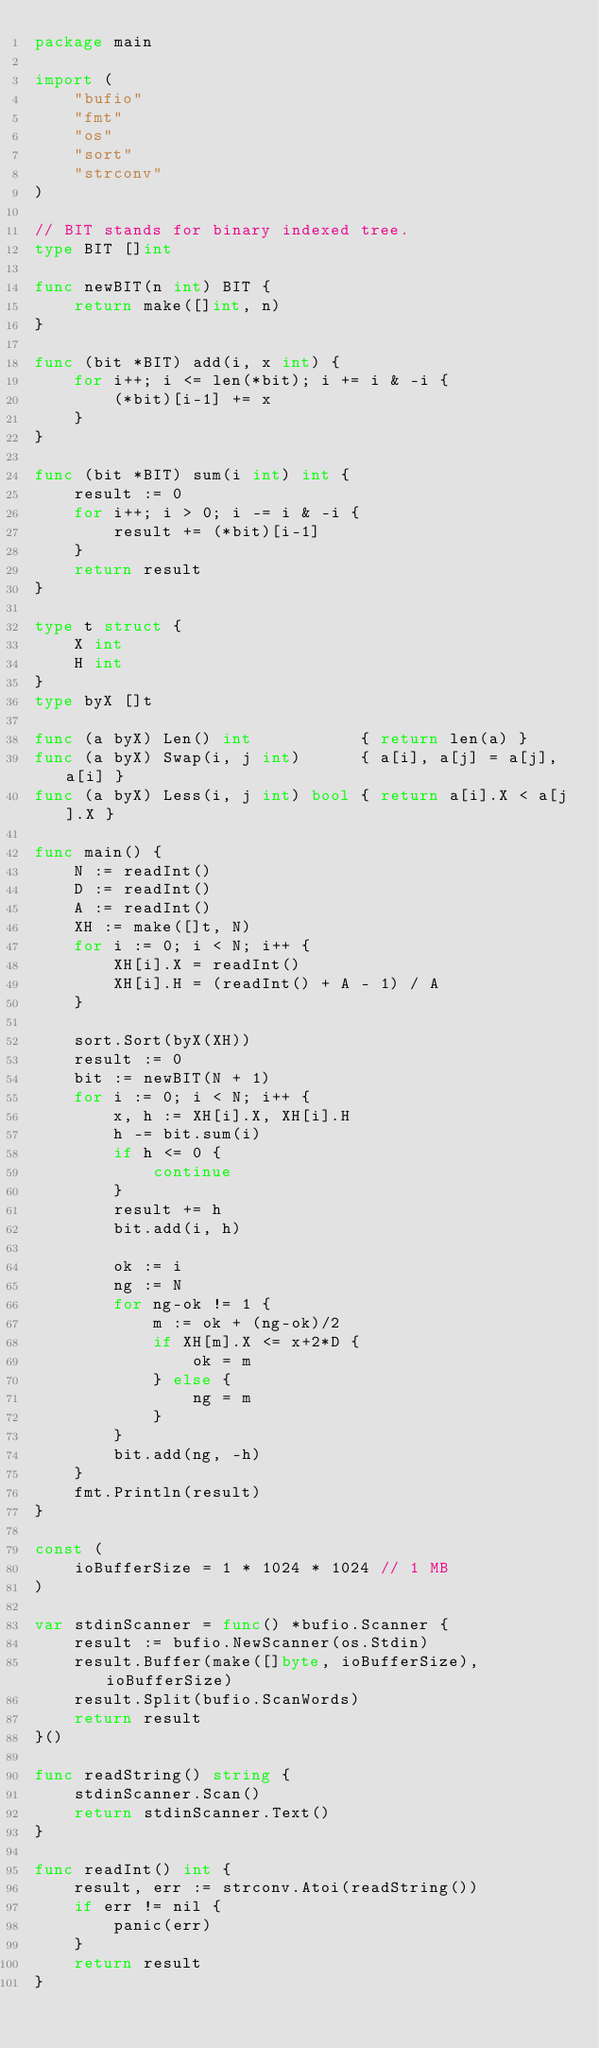Convert code to text. <code><loc_0><loc_0><loc_500><loc_500><_Go_>package main

import (
	"bufio"
	"fmt"
	"os"
	"sort"
	"strconv"
)

// BIT stands for binary indexed tree.
type BIT []int

func newBIT(n int) BIT {
	return make([]int, n)
}

func (bit *BIT) add(i, x int) {
	for i++; i <= len(*bit); i += i & -i {
		(*bit)[i-1] += x
	}
}

func (bit *BIT) sum(i int) int {
	result := 0
	for i++; i > 0; i -= i & -i {
		result += (*bit)[i-1]
	}
	return result
}

type t struct {
	X int
	H int
}
type byX []t

func (a byX) Len() int           { return len(a) }
func (a byX) Swap(i, j int)      { a[i], a[j] = a[j], a[i] }
func (a byX) Less(i, j int) bool { return a[i].X < a[j].X }

func main() {
	N := readInt()
	D := readInt()
	A := readInt()
	XH := make([]t, N)
	for i := 0; i < N; i++ {
		XH[i].X = readInt()
		XH[i].H = (readInt() + A - 1) / A
	}

	sort.Sort(byX(XH))
	result := 0
	bit := newBIT(N + 1)
	for i := 0; i < N; i++ {
		x, h := XH[i].X, XH[i].H
		h -= bit.sum(i)
		if h <= 0 {
			continue
		}
		result += h
		bit.add(i, h)

		ok := i
		ng := N
		for ng-ok != 1 {
			m := ok + (ng-ok)/2
			if XH[m].X <= x+2*D {
				ok = m
			} else {
				ng = m
			}
		}
		bit.add(ng, -h)
	}
	fmt.Println(result)
}

const (
	ioBufferSize = 1 * 1024 * 1024 // 1 MB
)

var stdinScanner = func() *bufio.Scanner {
	result := bufio.NewScanner(os.Stdin)
	result.Buffer(make([]byte, ioBufferSize), ioBufferSize)
	result.Split(bufio.ScanWords)
	return result
}()

func readString() string {
	stdinScanner.Scan()
	return stdinScanner.Text()
}

func readInt() int {
	result, err := strconv.Atoi(readString())
	if err != nil {
		panic(err)
	}
	return result
}
</code> 